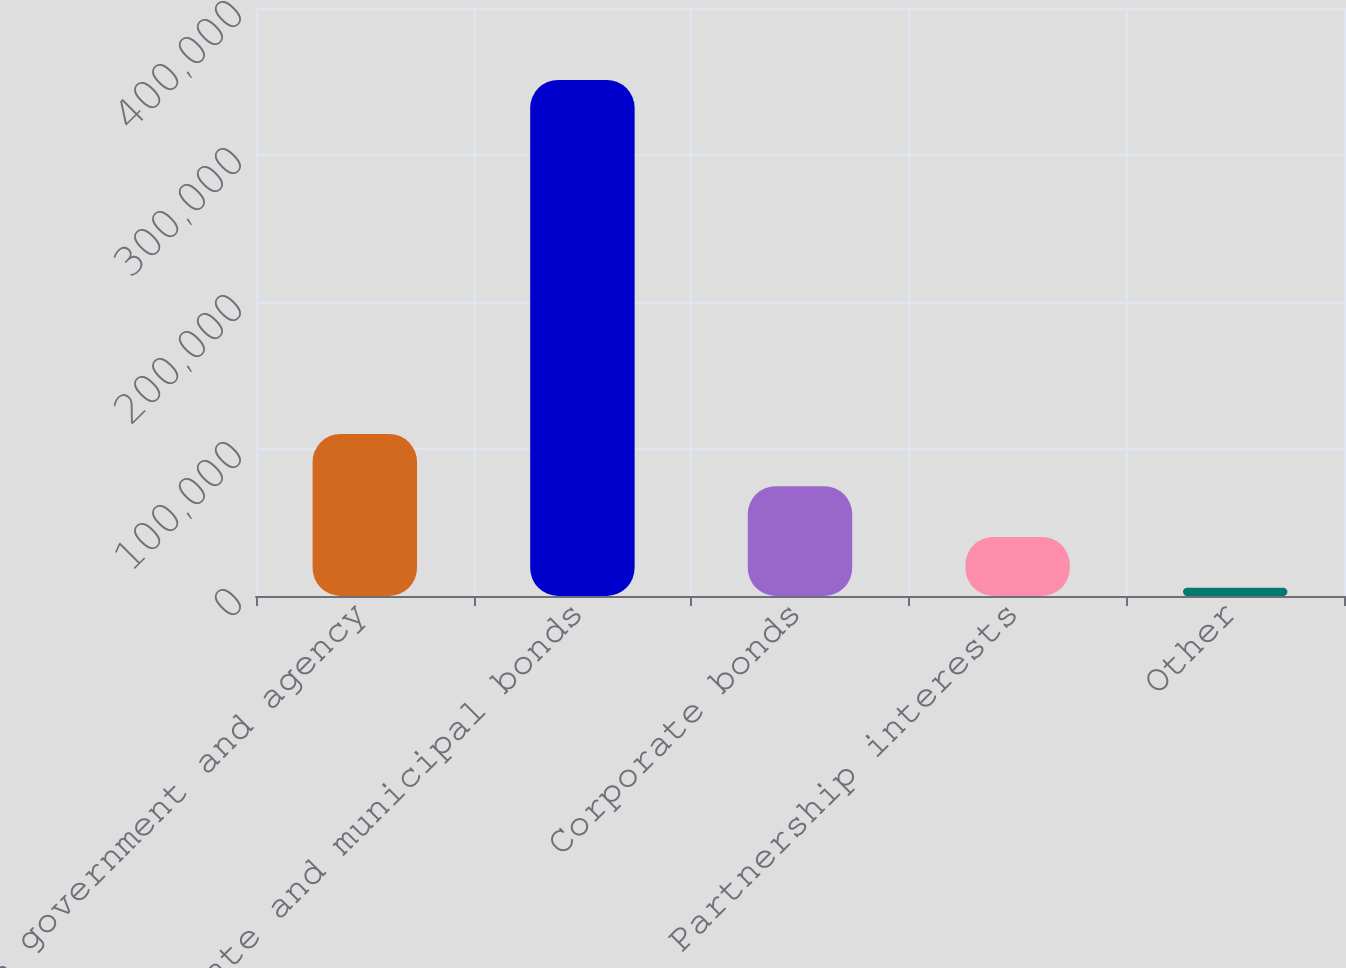Convert chart to OTSL. <chart><loc_0><loc_0><loc_500><loc_500><bar_chart><fcel>US government and agency<fcel>State and municipal bonds<fcel>Corporate bonds<fcel>Partnership interests<fcel>Other<nl><fcel>110214<fcel>351089<fcel>74740.2<fcel>40196.6<fcel>5653<nl></chart> 